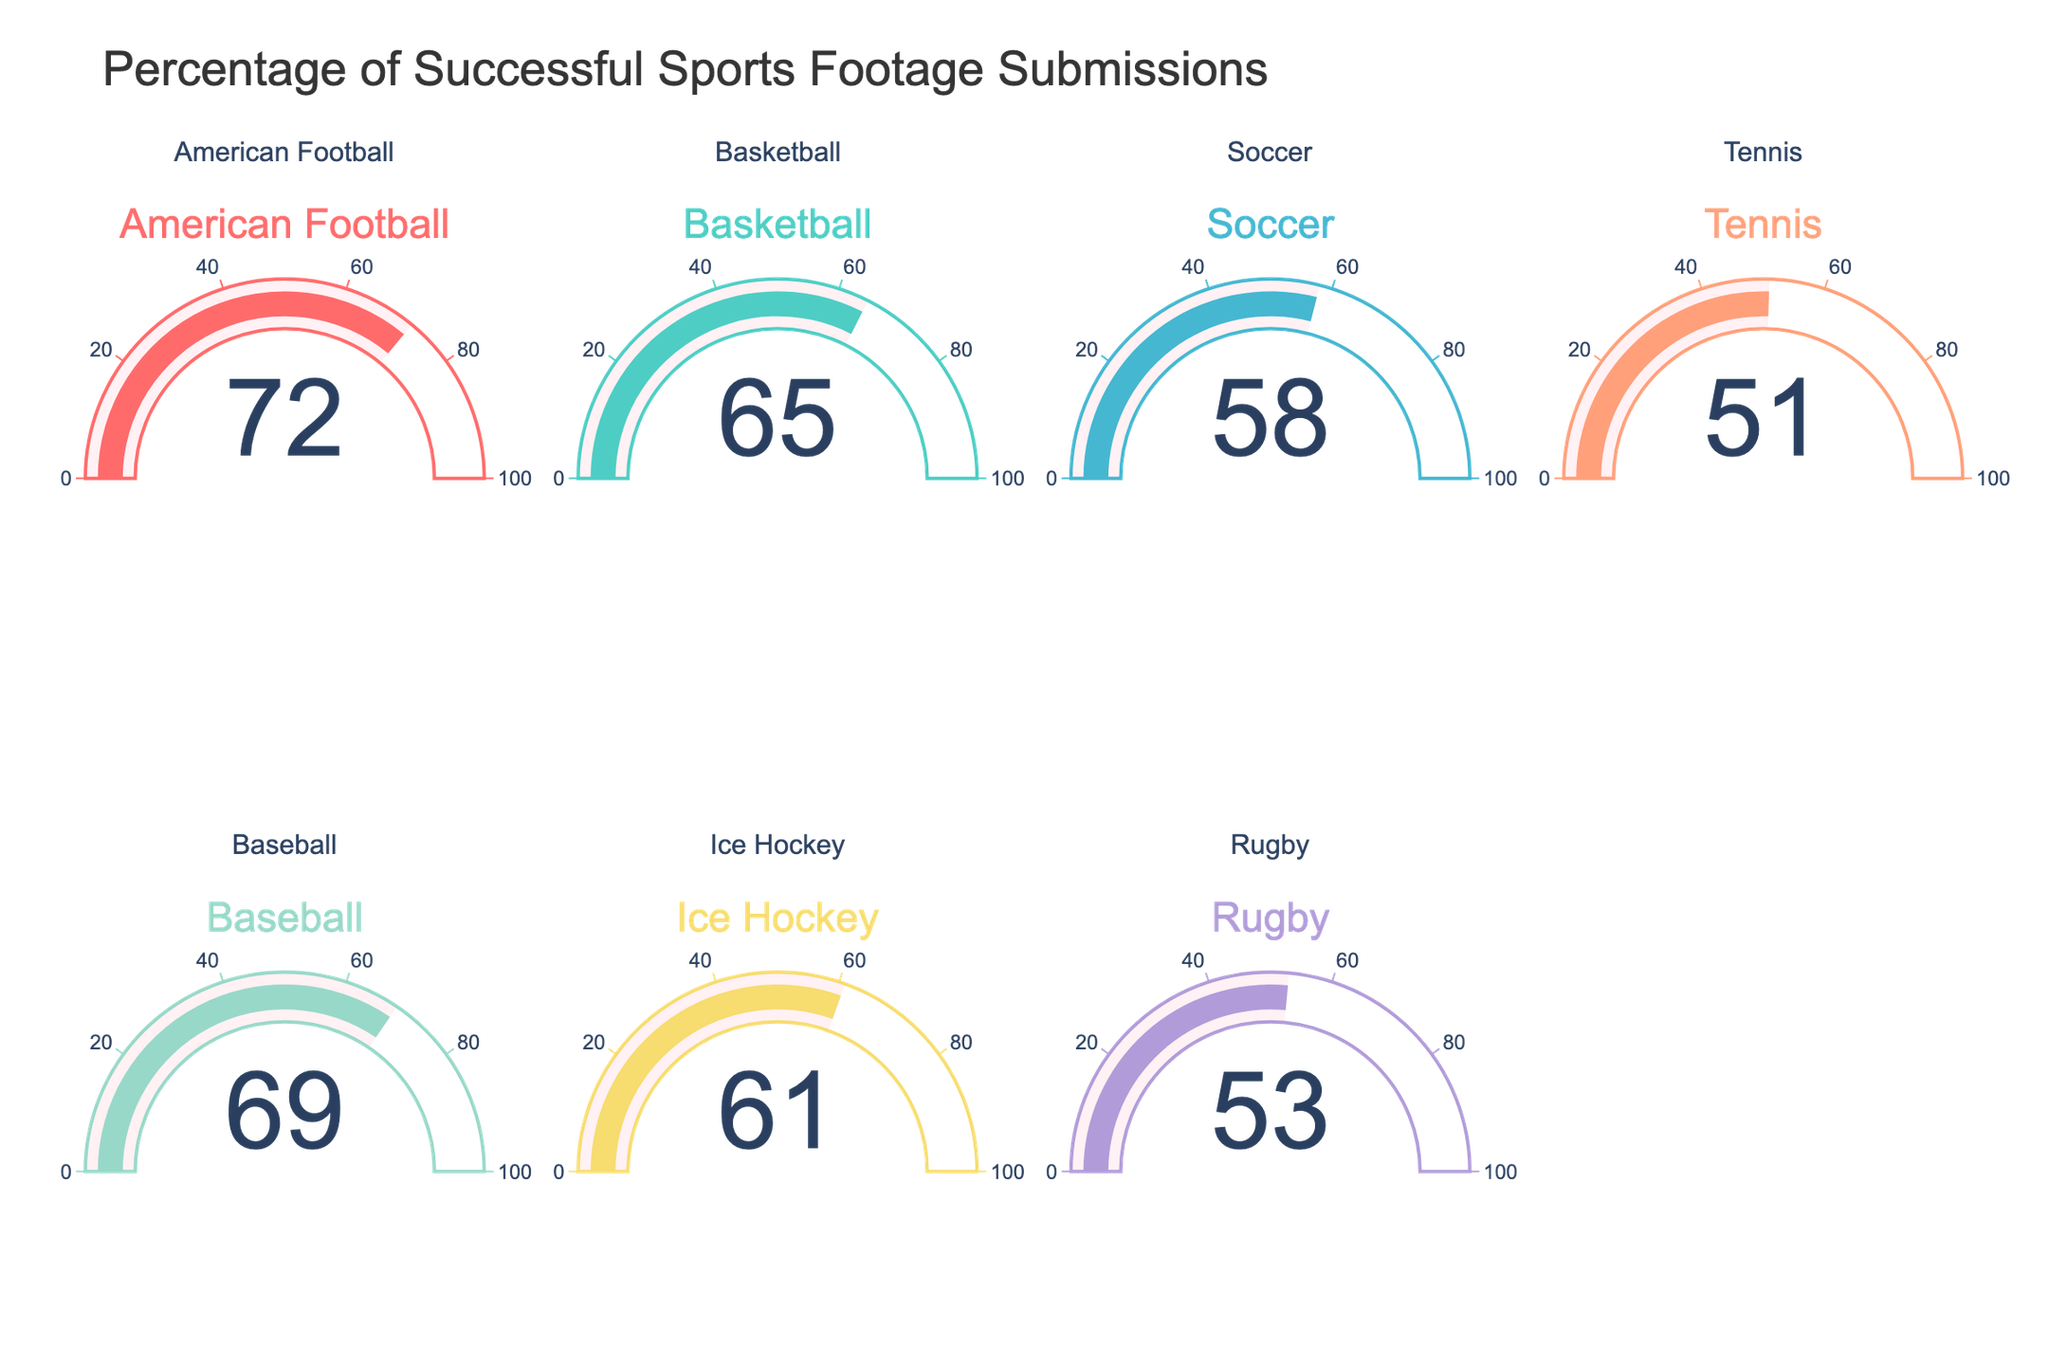Which sport has the highest acceptance rate? By looking at the gauges in the figure, the sport with the highest acceptance rate is identified as American Football. The dial shows a number indicating that 72% of submissions are accepted for this sport.
Answer: American Football Which sport has the lowest acceptance rate? Inspecting each gauge, the sport with the lowest acceptance rate is observed to be Tennis, which has only 51% of submissions accepted.
Answer: Tennis What is the average acceptance rate across all sports? To find the average, sum all the acceptance rates: 72 + 65 + 58 + 51 + 69 + 61 + 53 = 429. Then, divide by the number of sports, which is 7. Therefore, the average acceptance rate is 429 / 7 = 61.3%.
Answer: 61.3% What's the difference in acceptance rate between American Football and Tennis? According to the gauges, American Football has an acceptance rate of 72% while Tennis has 51%. Subtracting these values gives 72 - 51 = 21%.
Answer: 21% Which sports have an acceptance rate above 60%? From the gauges, American Football (72%), Basketball (65%), Baseball (69%), and Ice Hockey (61%) all have acceptance rates above 60%.
Answer: American Football, Basketball, Baseball, Ice Hockey How much higher is the acceptance rate for Baseball compared to Rugby? The gauge for Baseball shows a 69% acceptance rate while Rugby has 53%. Therefore, the difference is 69% - 53% = 16%.
Answer: 16% Which sports have acceptance rates between 50% and 60%? Scrutinizing the gauges, Soccer (58%), Tennis (51%), and Rugby (53%) fall within the 50%-60% range.
Answer: Soccer, Tennis, Rugby What's the combined acceptance rate for Soccer and Ice Hockey? Adding the acceptance rates from the gauges, Soccer has 58% and Ice Hockey has 61%. So, the combined rate is 58% + 61% = 119%.
Answer: 119% Is the median acceptance rate higher than 60%? To find the median, sort the acceptance rates: 51, 53, 58, 61, 65, 69, 72. The median is the middle value in this case, which is 61%. Since 61% is higher than 60%, the answer is yes.
Answer: Yes 